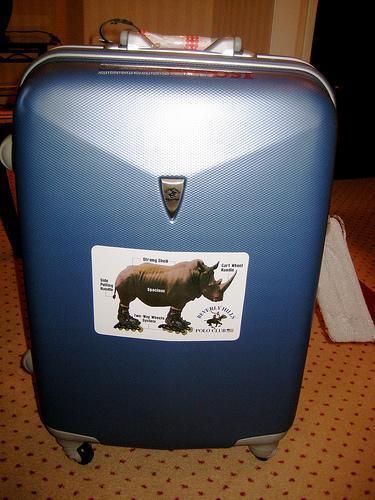How many rhino stickers are visible?
Give a very brief answer. 1. 